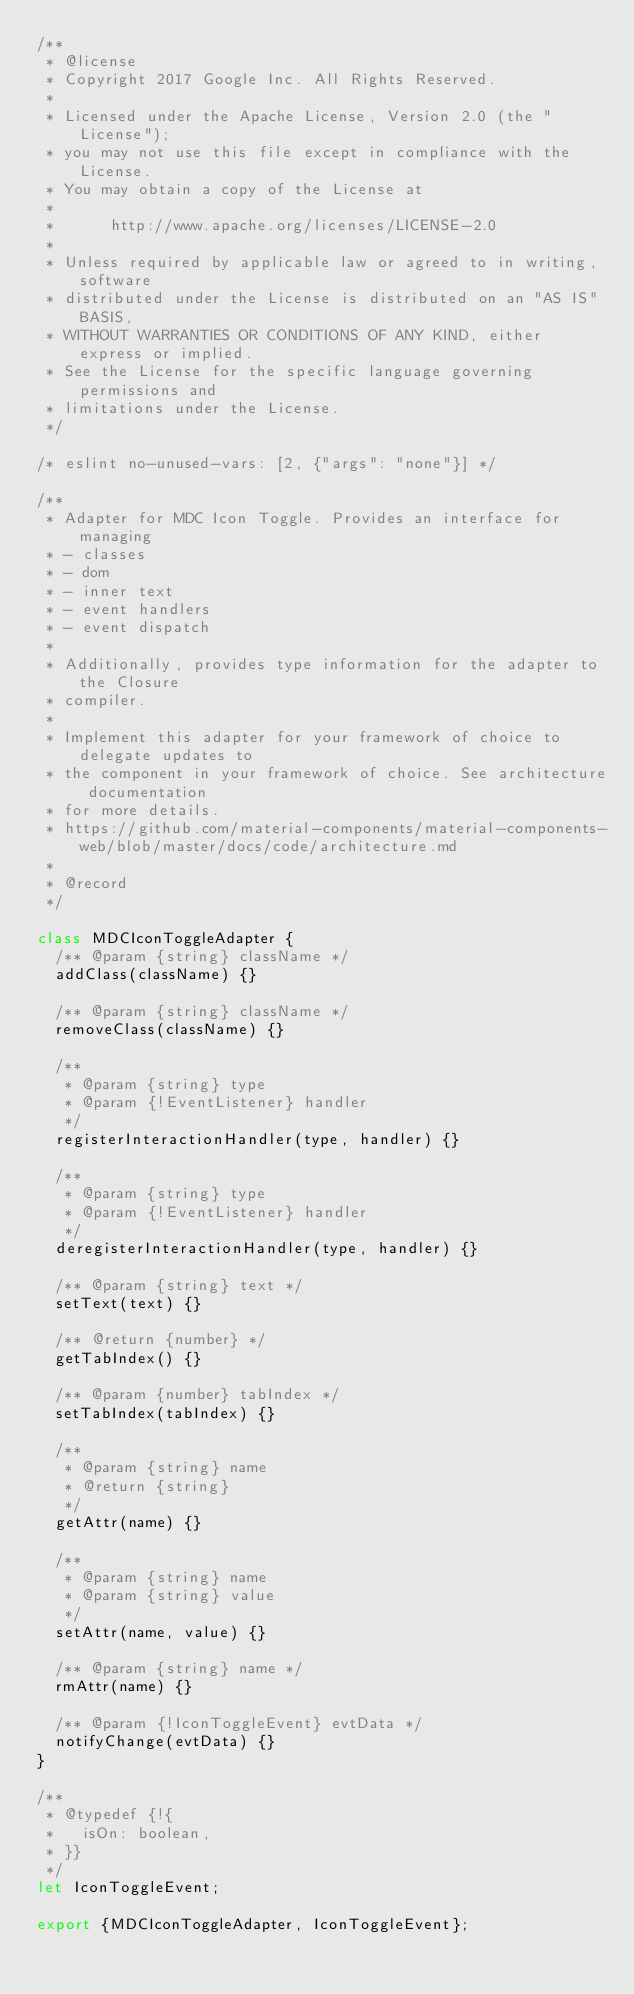<code> <loc_0><loc_0><loc_500><loc_500><_JavaScript_>/**
 * @license
 * Copyright 2017 Google Inc. All Rights Reserved.
 *
 * Licensed under the Apache License, Version 2.0 (the "License");
 * you may not use this file except in compliance with the License.
 * You may obtain a copy of the License at
 *
 *      http://www.apache.org/licenses/LICENSE-2.0
 *
 * Unless required by applicable law or agreed to in writing, software
 * distributed under the License is distributed on an "AS IS" BASIS,
 * WITHOUT WARRANTIES OR CONDITIONS OF ANY KIND, either express or implied.
 * See the License for the specific language governing permissions and
 * limitations under the License.
 */

/* eslint no-unused-vars: [2, {"args": "none"}] */

/**
 * Adapter for MDC Icon Toggle. Provides an interface for managing
 * - classes
 * - dom
 * - inner text
 * - event handlers
 * - event dispatch
 *
 * Additionally, provides type information for the adapter to the Closure
 * compiler.
 *
 * Implement this adapter for your framework of choice to delegate updates to
 * the component in your framework of choice. See architecture documentation
 * for more details.
 * https://github.com/material-components/material-components-web/blob/master/docs/code/architecture.md
 *
 * @record
 */

class MDCIconToggleAdapter {
  /** @param {string} className */
  addClass(className) {}

  /** @param {string} className */
  removeClass(className) {}

  /**
   * @param {string} type
   * @param {!EventListener} handler
   */
  registerInteractionHandler(type, handler) {}

  /**
   * @param {string} type
   * @param {!EventListener} handler
   */
  deregisterInteractionHandler(type, handler) {}

  /** @param {string} text */
  setText(text) {}

  /** @return {number} */
  getTabIndex() {}

  /** @param {number} tabIndex */
  setTabIndex(tabIndex) {}

  /**
   * @param {string} name
   * @return {string}
   */
  getAttr(name) {}

  /**
   * @param {string} name
   * @param {string} value
   */
  setAttr(name, value) {}

  /** @param {string} name */
  rmAttr(name) {}

  /** @param {!IconToggleEvent} evtData */
  notifyChange(evtData) {}
}

/**
 * @typedef {!{
 *   isOn: boolean,
 * }}
 */
let IconToggleEvent;

export {MDCIconToggleAdapter, IconToggleEvent};
</code> 